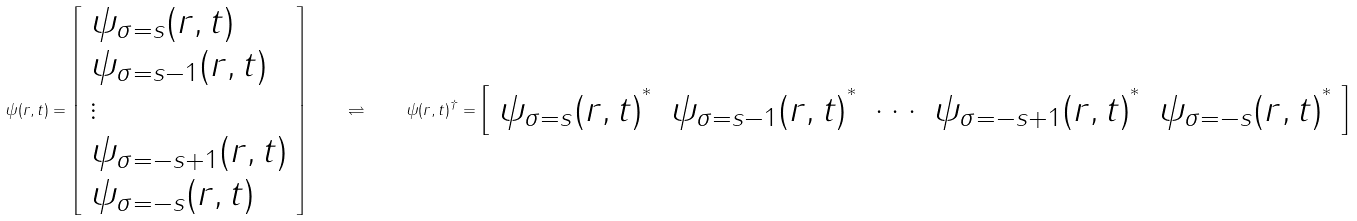<formula> <loc_0><loc_0><loc_500><loc_500>\psi ( r , t ) = { \left [ \begin{array} { l } { \psi _ { \sigma = s } ( r , t ) } \\ { \psi _ { \sigma = s - 1 } ( r , t ) } \\ { \vdots } \\ { \psi _ { \sigma = - s + 1 } ( r , t ) } \\ { \psi _ { \sigma = - s } ( r , t ) } \end{array} \right ] } \quad \rightleftharpoons \quad \psi ( r , t ) ^ { \dagger } = { \left [ \begin{array} { l l l l l } { { \psi _ { \sigma = s } ( r , t ) } ^ { ^ { * } } } & { { \psi _ { \sigma = s - 1 } ( r , t ) } ^ { ^ { * } } } & { \cdots } & { { \psi _ { \sigma = - s + 1 } ( r , t ) } ^ { ^ { * } } } & { { \psi _ { \sigma = - s } ( r , t ) } ^ { ^ { * } } } \end{array} \right ] }</formula> 